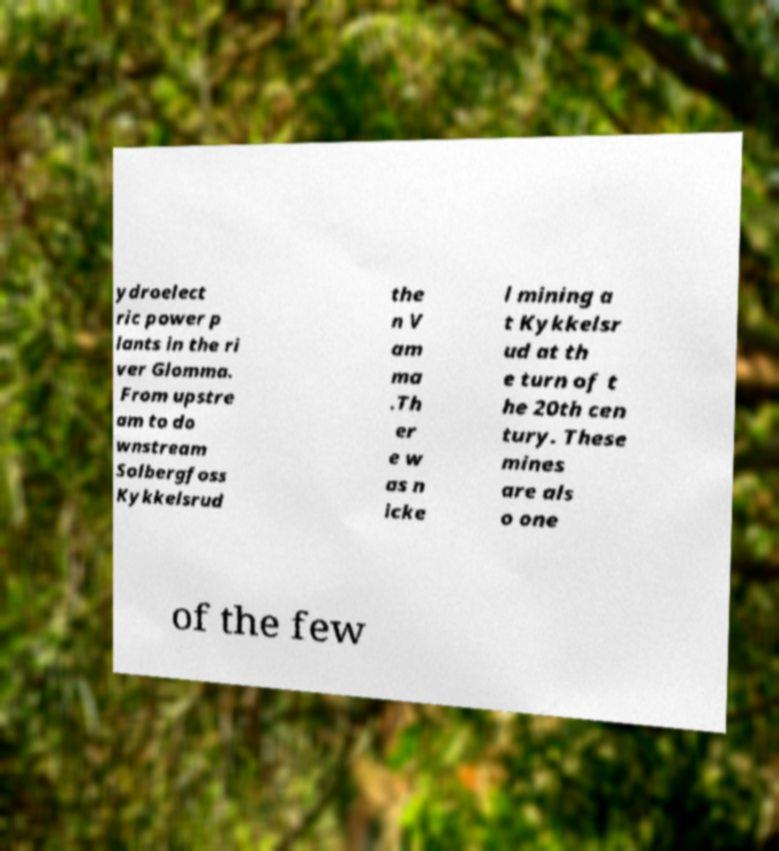For documentation purposes, I need the text within this image transcribed. Could you provide that? ydroelect ric power p lants in the ri ver Glomma. From upstre am to do wnstream Solbergfoss Kykkelsrud the n V am ma .Th er e w as n icke l mining a t Kykkelsr ud at th e turn of t he 20th cen tury. These mines are als o one of the few 